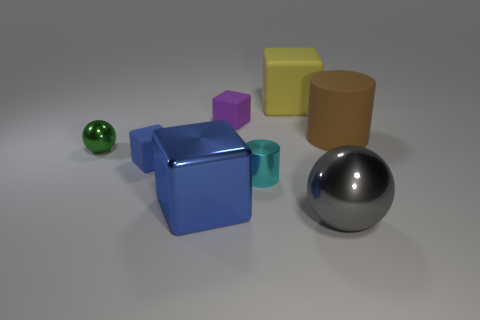What is the shape of the small object that is the same color as the big shiny cube?
Provide a short and direct response. Cube. Do the small purple block and the yellow thing have the same material?
Keep it short and to the point. Yes. How many other things are there of the same size as the green metallic ball?
Your response must be concise. 3. What is the size of the metal object that is behind the cylinder left of the big gray shiny thing?
Provide a short and direct response. Small. The tiny cube left of the small matte object behind the small metal object left of the small purple block is what color?
Give a very brief answer. Blue. There is a object that is both to the right of the large matte cube and in front of the green metal thing; what size is it?
Provide a short and direct response. Large. How many other objects are the same shape as the big blue metallic thing?
Your answer should be compact. 3. What number of balls are either yellow things or tiny green objects?
Offer a terse response. 1. There is a cylinder that is in front of the ball that is behind the large gray metallic object; is there a large object that is in front of it?
Your answer should be compact. Yes. There is another metallic thing that is the same shape as the large gray object; what is its color?
Keep it short and to the point. Green. 